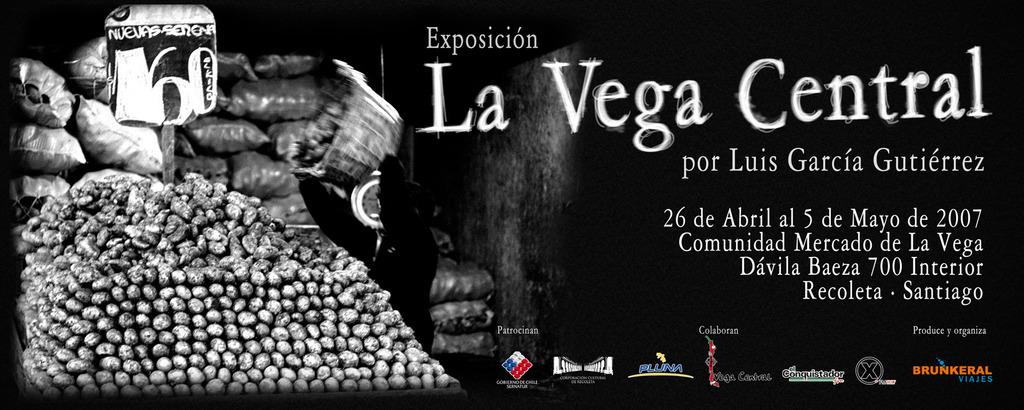What types of objects can be seen in the image? There are objects in the image, but we cannot determine their specific types from the given facts. What is the primary feature of the board in the image? There is a board in the image, but we cannot determine its specific features from the given facts. What are the bags used for in the image? There are bags in the image, but we cannot determine their purpose from the given facts. What does the text written on the image say? The text written on the image cannot be determined from the given facts. What color is the background of the image? The background of the image is black. What type of beef is being sorted on the territory in the image? There is no beef or territory present in the image. 